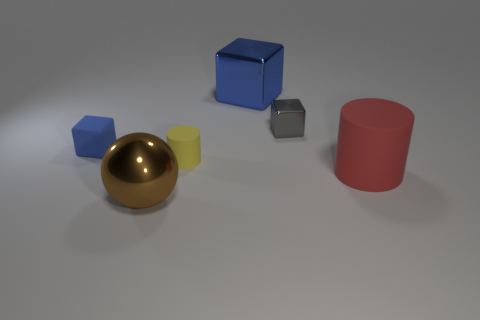How many cylinders are to the left of the small blue matte thing? 0 